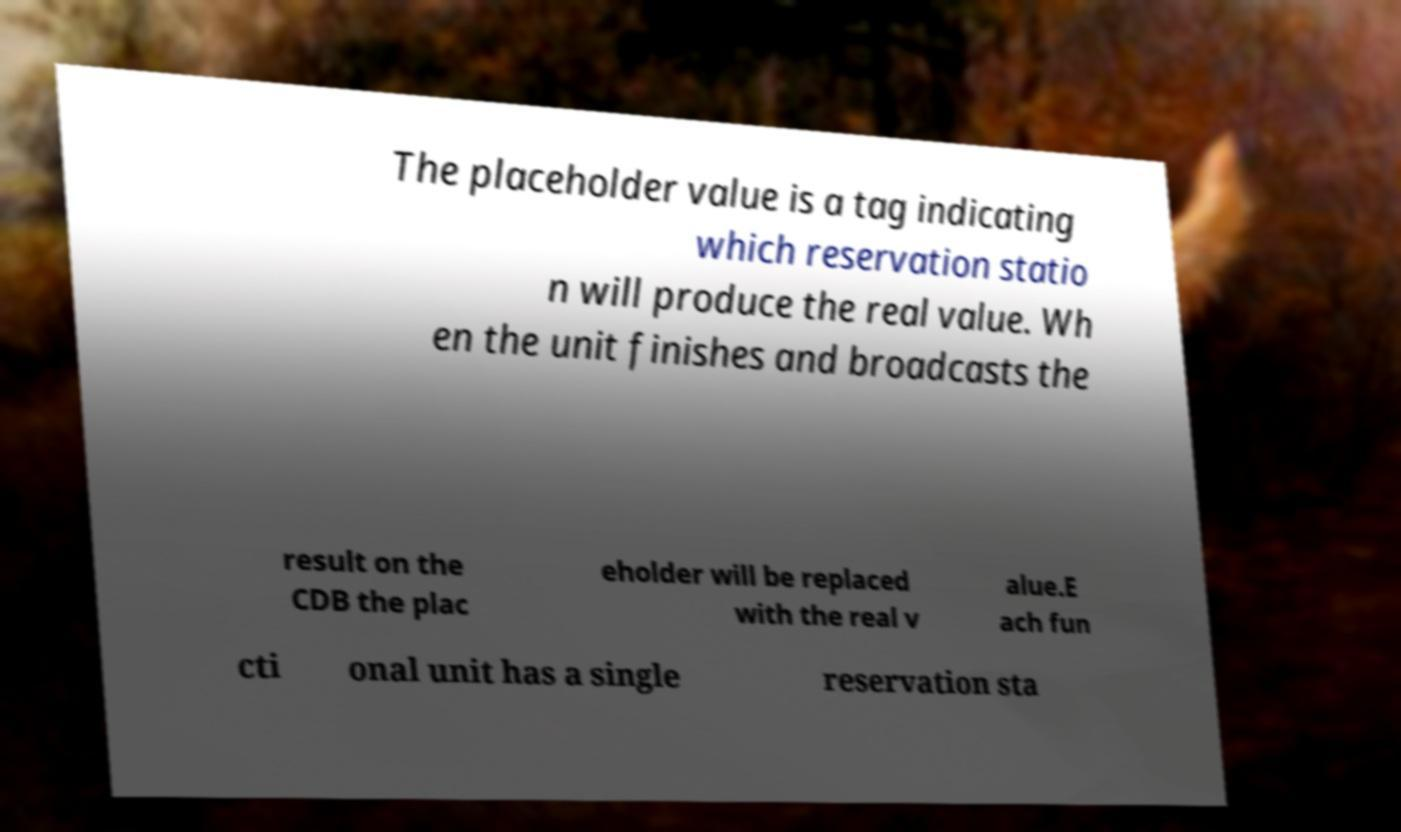For documentation purposes, I need the text within this image transcribed. Could you provide that? The placeholder value is a tag indicating which reservation statio n will produce the real value. Wh en the unit finishes and broadcasts the result on the CDB the plac eholder will be replaced with the real v alue.E ach fun cti onal unit has a single reservation sta 